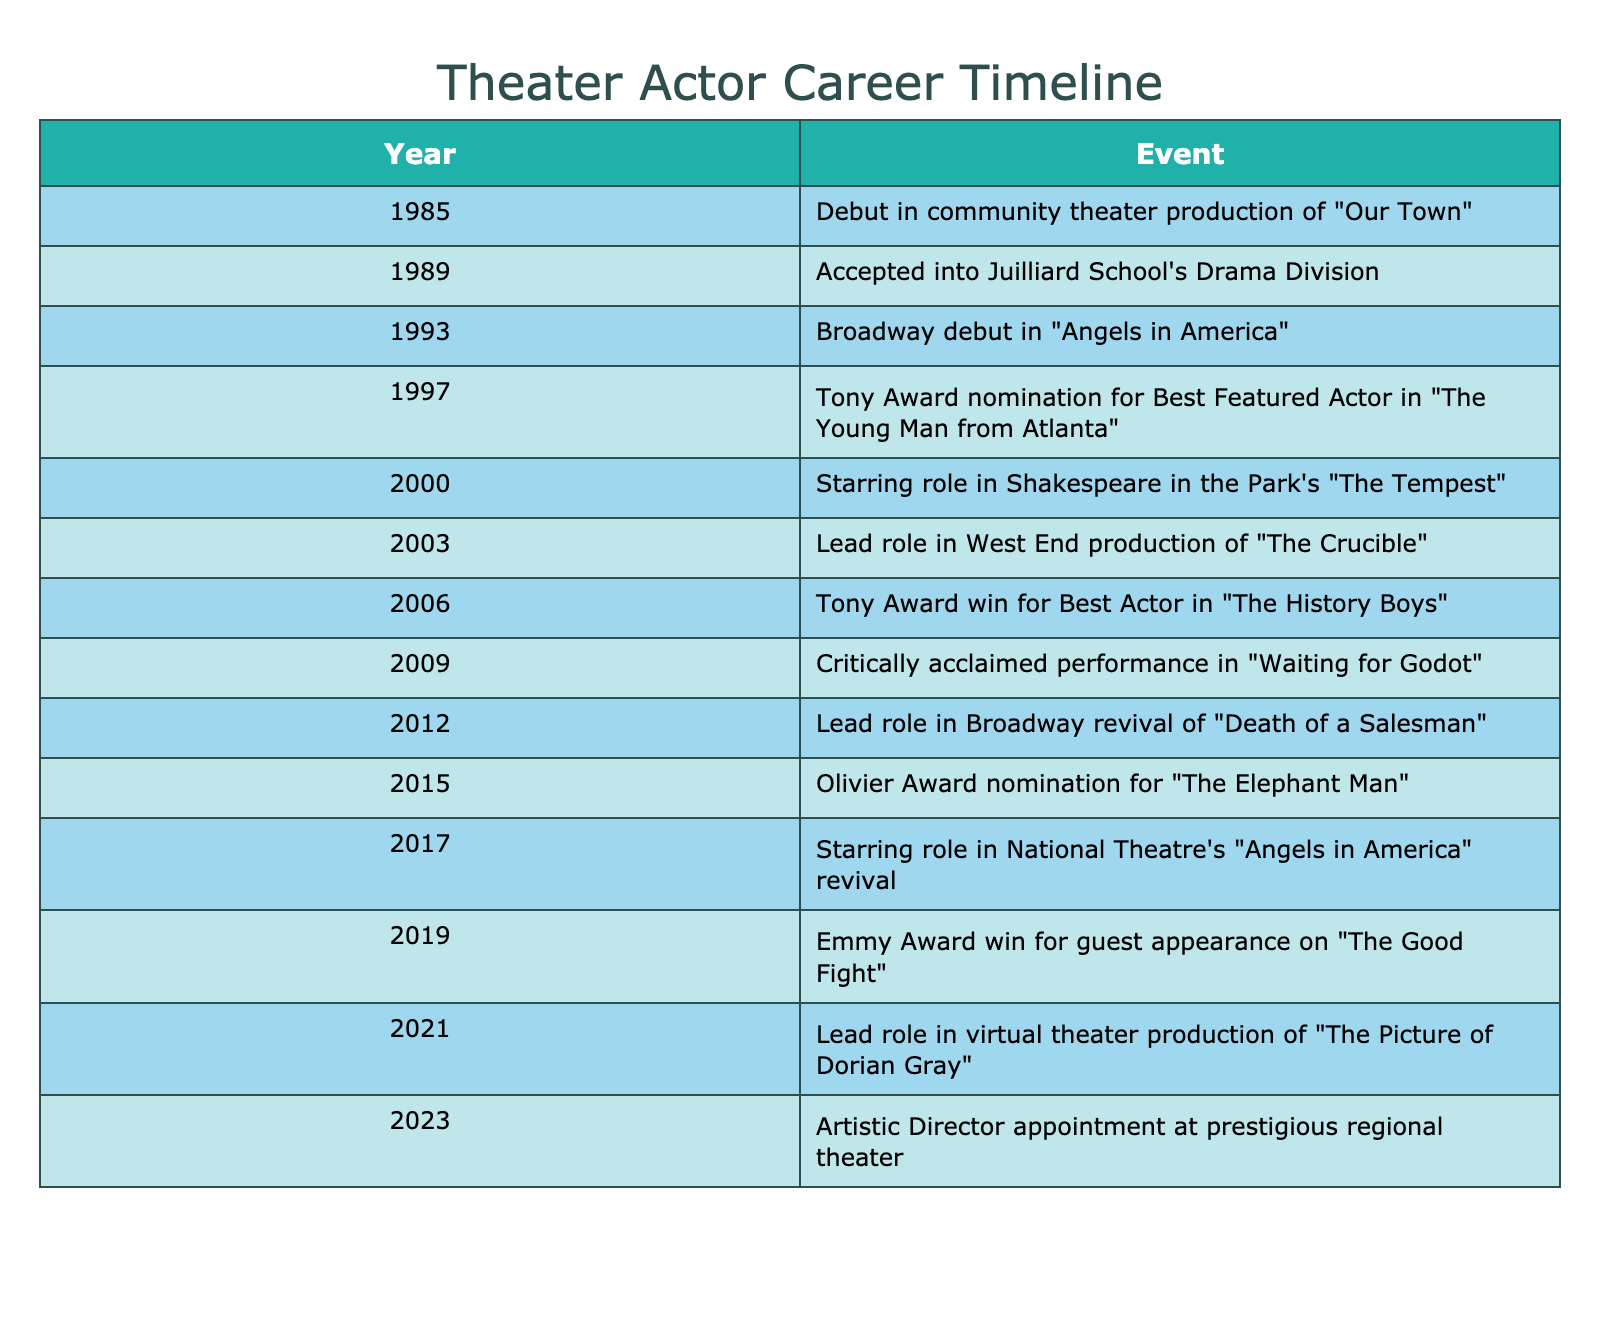What year did the actor win the Tony Award for Best Actor? The table indicates that the actor won the Tony Award for Best Actor in 2006.
Answer: 2006 What is the most recent notable role mentioned in the timeline? Looking at the last entry in the table, which is for the year 2023, the actor's most recent notable role is their appointment as the Artistic Director at a prestigious regional theater.
Answer: Artistic Director appointment at prestigious regional theater Which event occurred eight years after the Broadway debut? The Broadway debut occurred in 1993, and counting eight years forward, we arrive at 2001. However, the closest notable event in the table is the actor's starring role in "The Tempest" in 2000, which means there is no entry for exactly eight years later, but the significant next event is in 2003.
Answer: Starring role in Shakespeare in the Park's "The Tempest" in 2000 Did the actor receive any awards or nominations in the year 2015? Based on the table, the actor received an Olivier Award nomination in 2015, indicating they were acknowledged that year.
Answer: Yes How many significant events happened between 2000 and 2010? Looking at the table from 2000 to 2010, we identify the following events: "The Tempest" in 2000, "The Crucible" in 2003, the Tony Award win in 2006, and "Waiting for Godot" in 2009. This totals four events occurring in that decade.
Answer: 4 events 